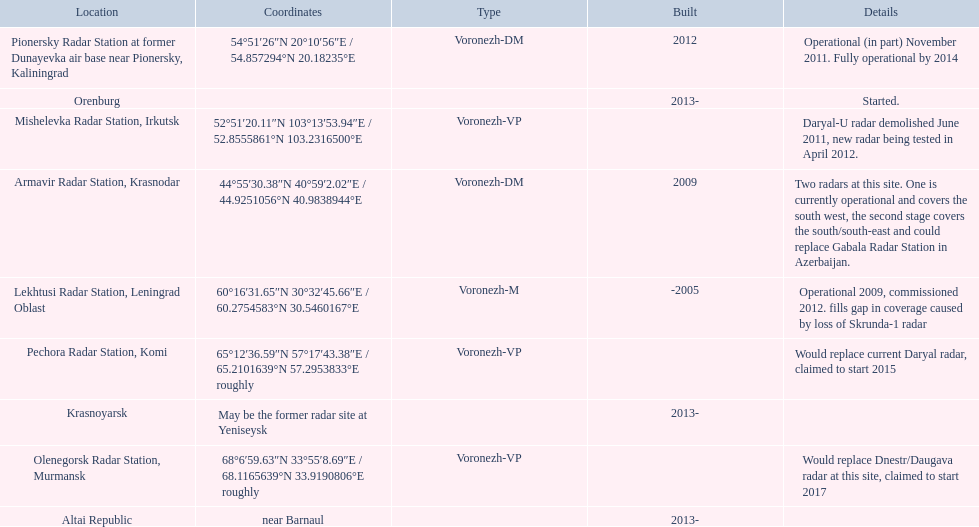What are the list of radar locations? Lekhtusi Radar Station, Leningrad Oblast, Armavir Radar Station, Krasnodar, Pionersky Radar Station at former Dunayevka air base near Pionersky, Kaliningrad, Mishelevka Radar Station, Irkutsk, Pechora Radar Station, Komi, Olenegorsk Radar Station, Murmansk, Krasnoyarsk, Altai Republic, Orenburg. Which of these are claimed to start in 2015? Pechora Radar Station, Komi. 